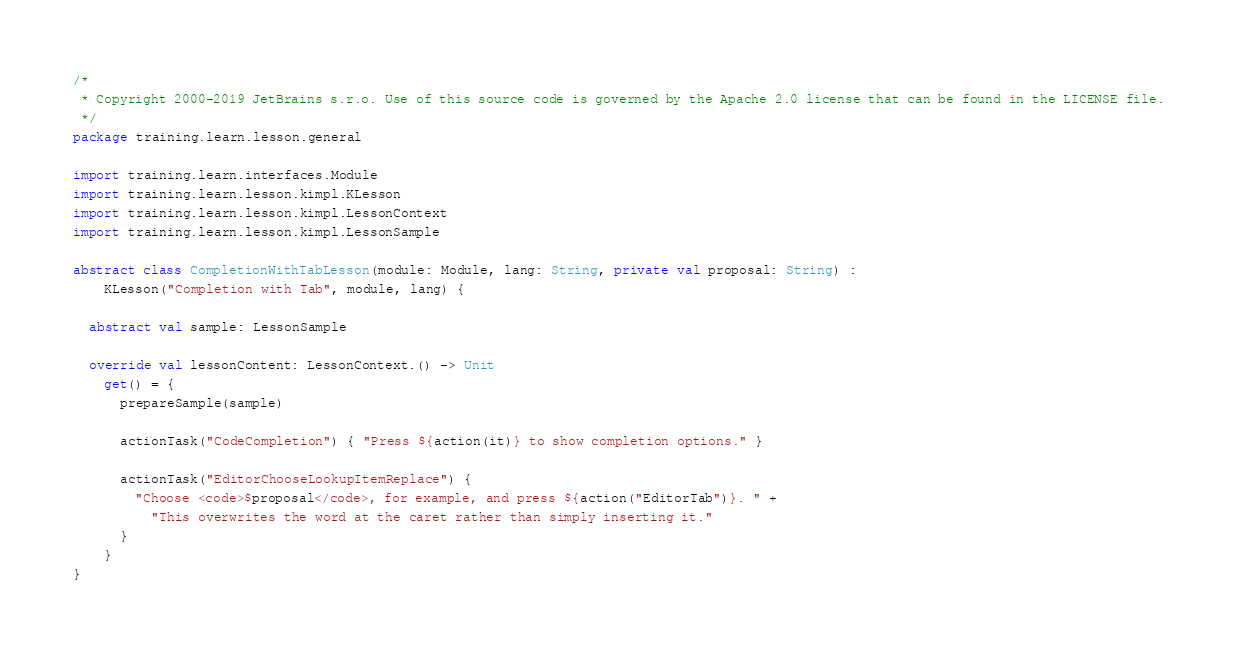<code> <loc_0><loc_0><loc_500><loc_500><_Kotlin_>/*
 * Copyright 2000-2019 JetBrains s.r.o. Use of this source code is governed by the Apache 2.0 license that can be found in the LICENSE file.
 */
package training.learn.lesson.general

import training.learn.interfaces.Module
import training.learn.lesson.kimpl.KLesson
import training.learn.lesson.kimpl.LessonContext
import training.learn.lesson.kimpl.LessonSample

abstract class CompletionWithTabLesson(module: Module, lang: String, private val proposal: String) :
    KLesson("Completion with Tab", module, lang) {

  abstract val sample: LessonSample

  override val lessonContent: LessonContext.() -> Unit
    get() = {
      prepareSample(sample)

      actionTask("CodeCompletion") { "Press ${action(it)} to show completion options." }

      actionTask("EditorChooseLookupItemReplace") {
        "Choose <code>$proposal</code>, for example, and press ${action("EditorTab")}. " +
          "This overwrites the word at the caret rather than simply inserting it."
      }
    }
}
</code> 